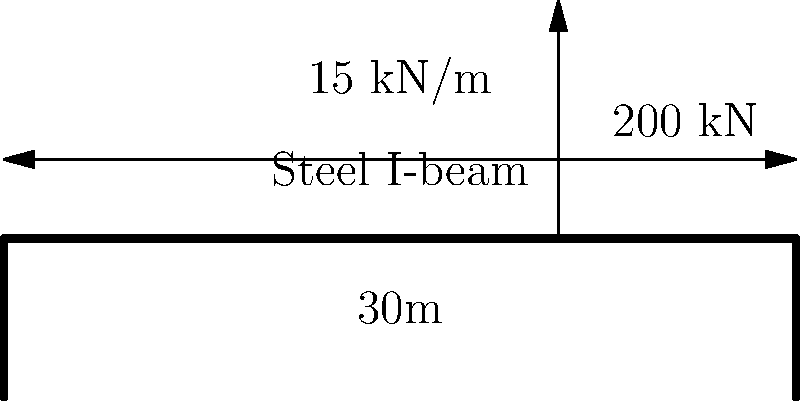A steel I-beam bridge spans 30 meters and is subjected to a uniformly distributed load of 15 kN/m along its entire length, as well as a point load of 200 kN at a distance of 21 meters from the left support. Given that the allowable bending stress for the steel is 165 MPa and the section modulus of the I-beam is 0.0085 m³, determine if the bridge can safely support these loads. To determine if the bridge can safely support the loads, we need to calculate the maximum bending moment and compare it to the allowable bending moment.

Step 1: Calculate the reaction forces at the supports.
Total distributed load: $15 \text{ kN/m} \times 30 \text{ m} = 450 \text{ kN}$
$\sum M_A = 0$: $R_B \times 30 - 450 \times 15 - 200 \times 21 = 0$
$R_B = 365 \text{ kN}$
$R_A = 450 + 200 - 365 = 285 \text{ kN}$

Step 2: Calculate the maximum bending moment.
The maximum bending moment will occur at the point load or at the point where the shear force is zero.

At the point load (21 m from left support):
$M = 285 \times 21 - 15 \times 21 \times 10.5 = 2835 \text{ kN·m}$

Step 3: Calculate the allowable bending moment.
Allowable bending moment = Allowable stress × Section modulus
$M_{allow} = 165 \times 10^6 \text{ Pa} \times 0.0085 \text{ m}^3 = 1402.5 \text{ kN·m}$

Step 4: Compare the maximum bending moment to the allowable bending moment.
Since $2835 \text{ kN·m} > 1402.5 \text{ kN·m}$, the bridge cannot safely support these loads.
Answer: No, the bridge cannot safely support the given loads. 